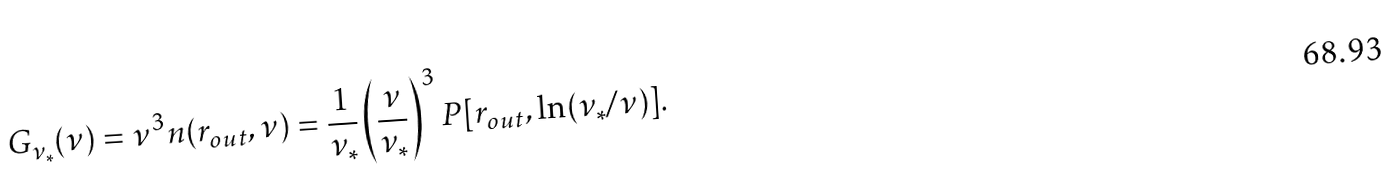Convert formula to latex. <formula><loc_0><loc_0><loc_500><loc_500>G _ { \nu _ { \ast } } ( \nu ) = \nu ^ { 3 } n ( r _ { o u t } , \nu ) = \frac { 1 } { \nu _ { \ast } } \left ( \frac { \nu } { \nu _ { \ast } } \right ) ^ { 3 } P [ r _ { o u t } , \ln ( \nu _ { \ast } / \nu ) ] .</formula> 